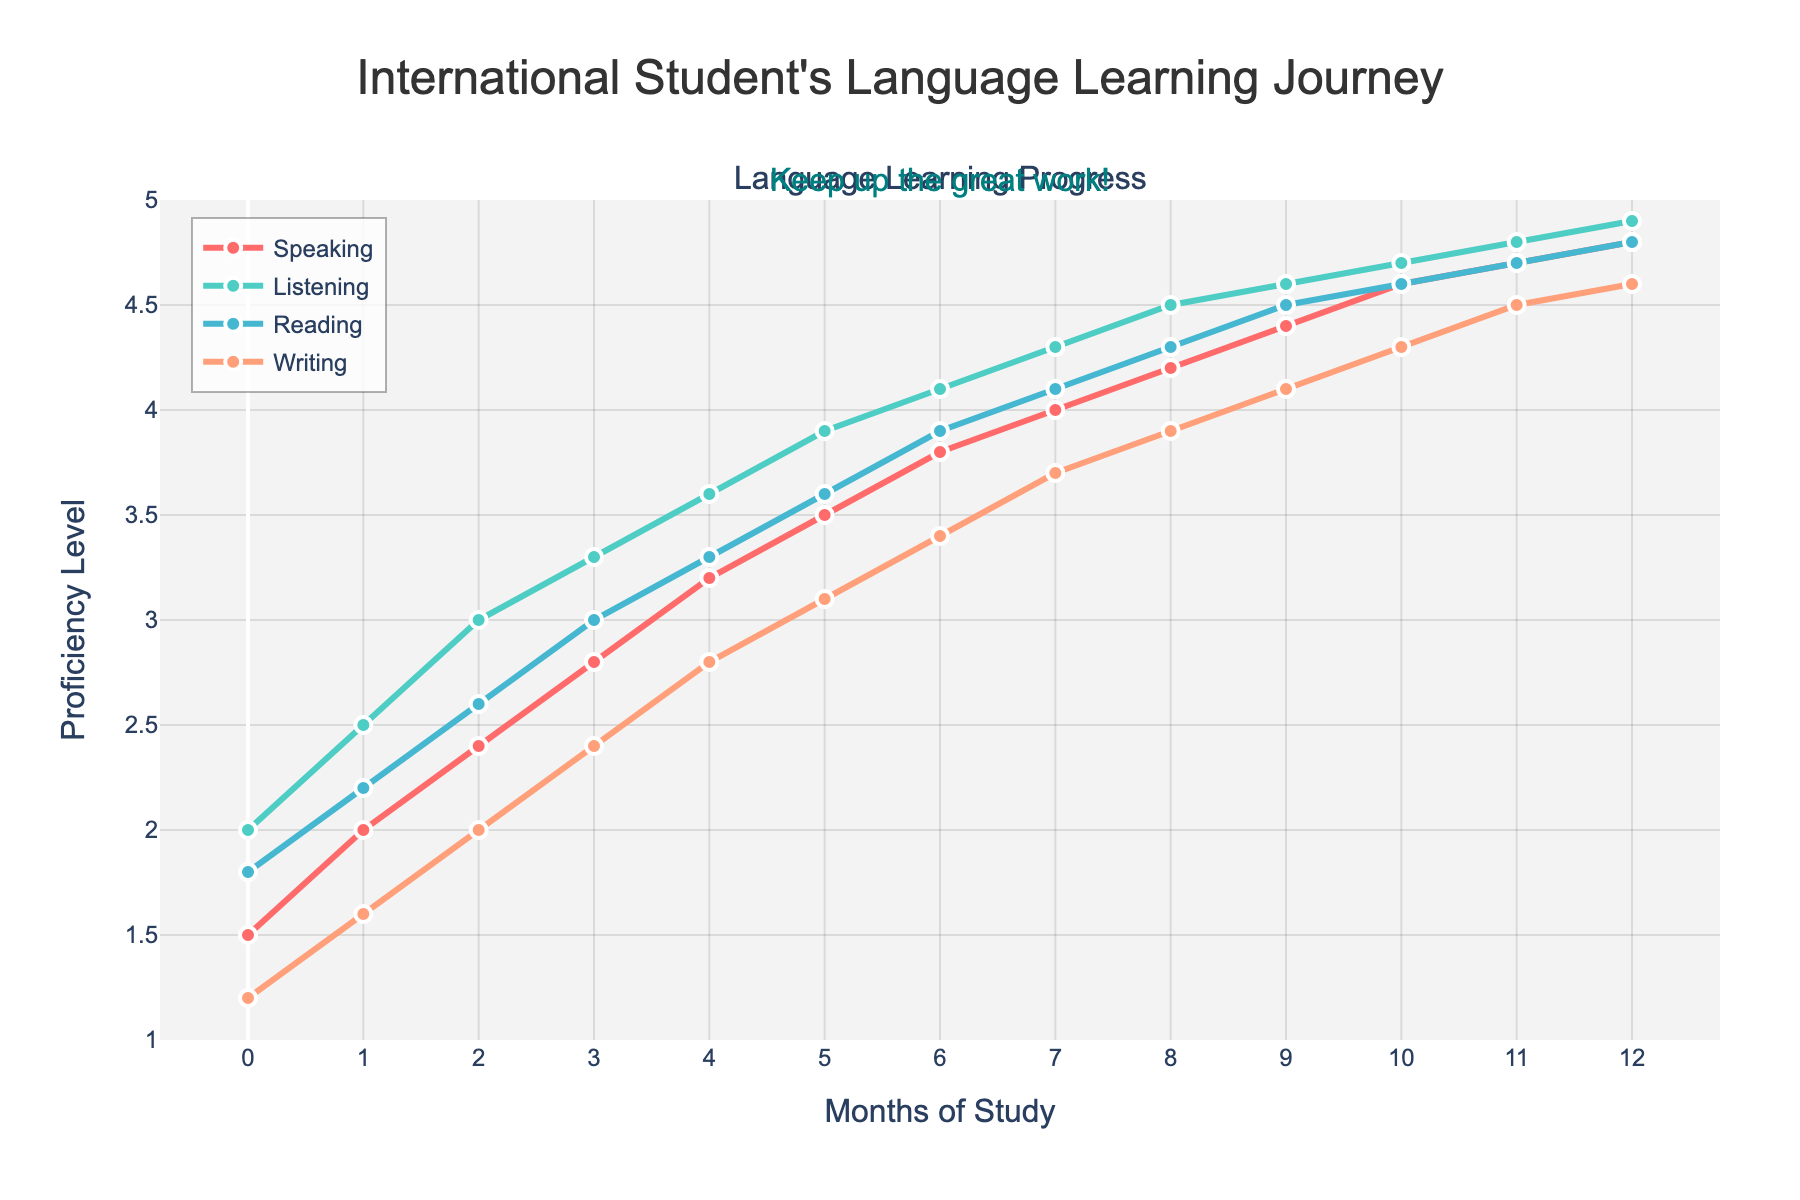How does the proficiency level in Speaking change over the 12 months? By observing the line representing Speaking, it starts at 1.5 in month 0 and ends at 4.8 in month 12. Each month shows consistent growth in proficiency.
Answer: It increases steadily Which skill shows the highest level of improvement? To determine the highest level of improvement, look at the end values (month 12) for all skills compared to their start values (month 0). Speaking improves from 1.5 to 4.8 (+3.3), Listening from 2.0 to 4.9 (+2.9), Reading from 1.8 to 4.8 (+3.0), Writing from 1.2 to 4.6 (+3.4). Hence, Writing shows the highest improvement.
Answer: Writing What is the highest proficiency level achieved in Listening? The highest proficiency level for Listening can be found at the peak of its respective line. It reaches 4.9 by month 12.
Answer: 4.9 By how much does the Reading proficiency level change between months 3 and 9? At month 3, Reading is at 3.0; at month 9, Reading is at 4.5. The change is calculated as 4.5 - 3.0.
Answer: 1.5 Is there any month where the proficiency in Writing exceeds the proficiency in Listening? By comparing the lines visually, Writing is always below Listening throughout the entire 12 months.
Answer: No Which month sees the steepest increase in proficiency for Speaking? To find the steepest increase, look for the segment in the Speaking line with the greatest slope. Between months 0 and 2 (1.5 to 2.4) and months 4 to 6 (3.2 to 3.8) are candidates; the steepest is between months 0 and 1 (1.5 to 2.0, a change of 0.5).
Answer: Month 0 to Month 1 How does the proficiency level of Writing compare to Speaking in month 8? Compare the points for Writing (3.9) and Speaking (4.2) in month 8. Writing is lower.
Answer: Writing is lower Which two skills have the closest proficiency levels in month 5? Check the values for all skills in month 5: Speaking (3.5), Listening (3.9), Reading (3.6), Writing (3.1). Reading and Speaking are the closest with a 0.1 difference.
Answer: Reading and Speaking 